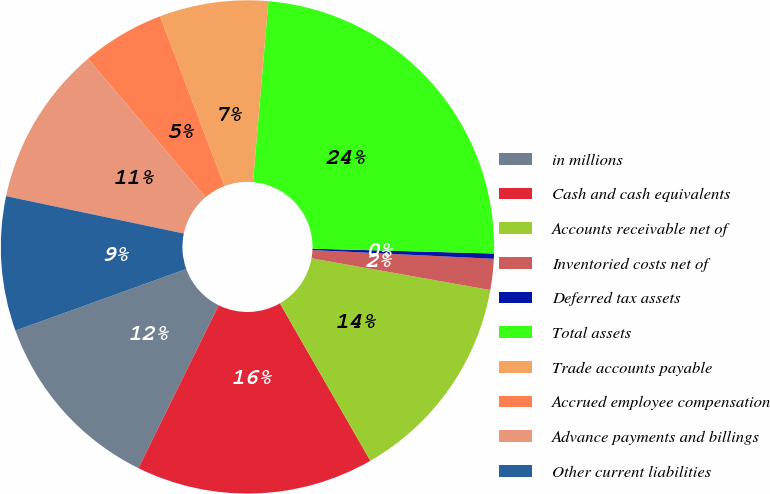Convert chart to OTSL. <chart><loc_0><loc_0><loc_500><loc_500><pie_chart><fcel>in millions<fcel>Cash and cash equivalents<fcel>Accounts receivable net of<fcel>Inventoried costs net of<fcel>Deferred tax assets<fcel>Total assets<fcel>Trade accounts payable<fcel>Accrued employee compensation<fcel>Advance payments and billings<fcel>Other current liabilities<nl><fcel>12.2%<fcel>15.59%<fcel>13.9%<fcel>2.03%<fcel>0.34%<fcel>24.07%<fcel>7.12%<fcel>5.42%<fcel>10.51%<fcel>8.81%<nl></chart> 